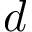<formula> <loc_0><loc_0><loc_500><loc_500>d</formula> 